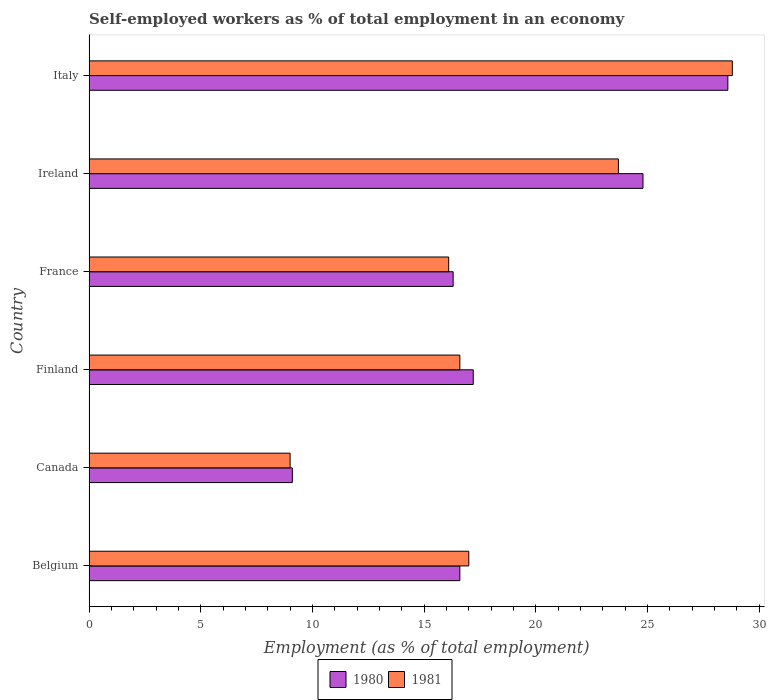How many bars are there on the 6th tick from the top?
Offer a terse response. 2. How many bars are there on the 6th tick from the bottom?
Provide a short and direct response. 2. What is the label of the 2nd group of bars from the top?
Offer a very short reply. Ireland. What is the percentage of self-employed workers in 1980 in Belgium?
Keep it short and to the point. 16.6. Across all countries, what is the maximum percentage of self-employed workers in 1981?
Provide a short and direct response. 28.8. Across all countries, what is the minimum percentage of self-employed workers in 1981?
Offer a very short reply. 9. In which country was the percentage of self-employed workers in 1981 minimum?
Offer a terse response. Canada. What is the total percentage of self-employed workers in 1981 in the graph?
Make the answer very short. 111.2. What is the difference between the percentage of self-employed workers in 1981 in Belgium and that in Italy?
Give a very brief answer. -11.8. What is the average percentage of self-employed workers in 1981 per country?
Your answer should be compact. 18.53. What is the difference between the percentage of self-employed workers in 1981 and percentage of self-employed workers in 1980 in Canada?
Your answer should be very brief. -0.1. In how many countries, is the percentage of self-employed workers in 1981 greater than 11 %?
Your answer should be compact. 5. What is the ratio of the percentage of self-employed workers in 1981 in Finland to that in France?
Offer a terse response. 1.03. Is the difference between the percentage of self-employed workers in 1981 in Belgium and Ireland greater than the difference between the percentage of self-employed workers in 1980 in Belgium and Ireland?
Your response must be concise. Yes. What is the difference between the highest and the second highest percentage of self-employed workers in 1980?
Keep it short and to the point. 3.8. What is the difference between the highest and the lowest percentage of self-employed workers in 1980?
Provide a succinct answer. 19.5. Is the sum of the percentage of self-employed workers in 1981 in Belgium and Finland greater than the maximum percentage of self-employed workers in 1980 across all countries?
Provide a short and direct response. Yes. What does the 2nd bar from the top in Italy represents?
Give a very brief answer. 1980. How many countries are there in the graph?
Provide a succinct answer. 6. What is the difference between two consecutive major ticks on the X-axis?
Offer a terse response. 5. Does the graph contain grids?
Provide a short and direct response. No. Where does the legend appear in the graph?
Ensure brevity in your answer.  Bottom center. How many legend labels are there?
Give a very brief answer. 2. What is the title of the graph?
Give a very brief answer. Self-employed workers as % of total employment in an economy. What is the label or title of the X-axis?
Make the answer very short. Employment (as % of total employment). What is the label or title of the Y-axis?
Provide a short and direct response. Country. What is the Employment (as % of total employment) of 1980 in Belgium?
Give a very brief answer. 16.6. What is the Employment (as % of total employment) in 1981 in Belgium?
Make the answer very short. 17. What is the Employment (as % of total employment) of 1980 in Canada?
Provide a short and direct response. 9.1. What is the Employment (as % of total employment) of 1981 in Canada?
Make the answer very short. 9. What is the Employment (as % of total employment) in 1980 in Finland?
Offer a very short reply. 17.2. What is the Employment (as % of total employment) of 1981 in Finland?
Your answer should be compact. 16.6. What is the Employment (as % of total employment) in 1980 in France?
Ensure brevity in your answer.  16.3. What is the Employment (as % of total employment) in 1981 in France?
Give a very brief answer. 16.1. What is the Employment (as % of total employment) of 1980 in Ireland?
Provide a short and direct response. 24.8. What is the Employment (as % of total employment) in 1981 in Ireland?
Your response must be concise. 23.7. What is the Employment (as % of total employment) in 1980 in Italy?
Make the answer very short. 28.6. What is the Employment (as % of total employment) in 1981 in Italy?
Your response must be concise. 28.8. Across all countries, what is the maximum Employment (as % of total employment) in 1980?
Provide a succinct answer. 28.6. Across all countries, what is the maximum Employment (as % of total employment) of 1981?
Provide a succinct answer. 28.8. Across all countries, what is the minimum Employment (as % of total employment) of 1980?
Keep it short and to the point. 9.1. Across all countries, what is the minimum Employment (as % of total employment) of 1981?
Offer a very short reply. 9. What is the total Employment (as % of total employment) in 1980 in the graph?
Provide a succinct answer. 112.6. What is the total Employment (as % of total employment) in 1981 in the graph?
Provide a short and direct response. 111.2. What is the difference between the Employment (as % of total employment) in 1980 in Belgium and that in Canada?
Your answer should be very brief. 7.5. What is the difference between the Employment (as % of total employment) of 1981 in Belgium and that in Canada?
Your response must be concise. 8. What is the difference between the Employment (as % of total employment) of 1980 in Belgium and that in Finland?
Your answer should be very brief. -0.6. What is the difference between the Employment (as % of total employment) of 1981 in Belgium and that in Finland?
Offer a very short reply. 0.4. What is the difference between the Employment (as % of total employment) of 1980 in Belgium and that in France?
Ensure brevity in your answer.  0.3. What is the difference between the Employment (as % of total employment) of 1981 in Belgium and that in Ireland?
Keep it short and to the point. -6.7. What is the difference between the Employment (as % of total employment) in 1981 in Belgium and that in Italy?
Offer a very short reply. -11.8. What is the difference between the Employment (as % of total employment) of 1980 in Canada and that in Finland?
Your response must be concise. -8.1. What is the difference between the Employment (as % of total employment) in 1981 in Canada and that in Finland?
Offer a very short reply. -7.6. What is the difference between the Employment (as % of total employment) of 1981 in Canada and that in France?
Offer a terse response. -7.1. What is the difference between the Employment (as % of total employment) in 1980 in Canada and that in Ireland?
Give a very brief answer. -15.7. What is the difference between the Employment (as % of total employment) in 1981 in Canada and that in Ireland?
Your answer should be compact. -14.7. What is the difference between the Employment (as % of total employment) in 1980 in Canada and that in Italy?
Offer a very short reply. -19.5. What is the difference between the Employment (as % of total employment) in 1981 in Canada and that in Italy?
Offer a very short reply. -19.8. What is the difference between the Employment (as % of total employment) in 1981 in Finland and that in France?
Your answer should be very brief. 0.5. What is the difference between the Employment (as % of total employment) of 1980 in Finland and that in Ireland?
Your response must be concise. -7.6. What is the difference between the Employment (as % of total employment) of 1981 in Finland and that in Italy?
Keep it short and to the point. -12.2. What is the difference between the Employment (as % of total employment) of 1981 in France and that in Italy?
Ensure brevity in your answer.  -12.7. What is the difference between the Employment (as % of total employment) of 1981 in Ireland and that in Italy?
Provide a succinct answer. -5.1. What is the difference between the Employment (as % of total employment) of 1980 in Belgium and the Employment (as % of total employment) of 1981 in Finland?
Provide a short and direct response. 0. What is the difference between the Employment (as % of total employment) of 1980 in Belgium and the Employment (as % of total employment) of 1981 in Italy?
Give a very brief answer. -12.2. What is the difference between the Employment (as % of total employment) of 1980 in Canada and the Employment (as % of total employment) of 1981 in France?
Your answer should be very brief. -7. What is the difference between the Employment (as % of total employment) of 1980 in Canada and the Employment (as % of total employment) of 1981 in Ireland?
Ensure brevity in your answer.  -14.6. What is the difference between the Employment (as % of total employment) of 1980 in Canada and the Employment (as % of total employment) of 1981 in Italy?
Your response must be concise. -19.7. What is the difference between the Employment (as % of total employment) of 1980 in Finland and the Employment (as % of total employment) of 1981 in France?
Keep it short and to the point. 1.1. What is the difference between the Employment (as % of total employment) in 1980 in Finland and the Employment (as % of total employment) in 1981 in Italy?
Provide a succinct answer. -11.6. What is the difference between the Employment (as % of total employment) in 1980 in France and the Employment (as % of total employment) in 1981 in Ireland?
Keep it short and to the point. -7.4. What is the difference between the Employment (as % of total employment) of 1980 in France and the Employment (as % of total employment) of 1981 in Italy?
Your response must be concise. -12.5. What is the difference between the Employment (as % of total employment) of 1980 in Ireland and the Employment (as % of total employment) of 1981 in Italy?
Provide a succinct answer. -4. What is the average Employment (as % of total employment) in 1980 per country?
Your response must be concise. 18.77. What is the average Employment (as % of total employment) in 1981 per country?
Provide a succinct answer. 18.53. What is the difference between the Employment (as % of total employment) in 1980 and Employment (as % of total employment) in 1981 in Belgium?
Keep it short and to the point. -0.4. What is the difference between the Employment (as % of total employment) in 1980 and Employment (as % of total employment) in 1981 in France?
Give a very brief answer. 0.2. What is the ratio of the Employment (as % of total employment) of 1980 in Belgium to that in Canada?
Offer a terse response. 1.82. What is the ratio of the Employment (as % of total employment) in 1981 in Belgium to that in Canada?
Offer a very short reply. 1.89. What is the ratio of the Employment (as % of total employment) in 1980 in Belgium to that in Finland?
Keep it short and to the point. 0.97. What is the ratio of the Employment (as % of total employment) of 1981 in Belgium to that in Finland?
Offer a very short reply. 1.02. What is the ratio of the Employment (as % of total employment) in 1980 in Belgium to that in France?
Make the answer very short. 1.02. What is the ratio of the Employment (as % of total employment) of 1981 in Belgium to that in France?
Provide a succinct answer. 1.06. What is the ratio of the Employment (as % of total employment) of 1980 in Belgium to that in Ireland?
Make the answer very short. 0.67. What is the ratio of the Employment (as % of total employment) in 1981 in Belgium to that in Ireland?
Offer a very short reply. 0.72. What is the ratio of the Employment (as % of total employment) in 1980 in Belgium to that in Italy?
Provide a short and direct response. 0.58. What is the ratio of the Employment (as % of total employment) in 1981 in Belgium to that in Italy?
Give a very brief answer. 0.59. What is the ratio of the Employment (as % of total employment) of 1980 in Canada to that in Finland?
Provide a short and direct response. 0.53. What is the ratio of the Employment (as % of total employment) of 1981 in Canada to that in Finland?
Your answer should be very brief. 0.54. What is the ratio of the Employment (as % of total employment) in 1980 in Canada to that in France?
Give a very brief answer. 0.56. What is the ratio of the Employment (as % of total employment) of 1981 in Canada to that in France?
Your answer should be very brief. 0.56. What is the ratio of the Employment (as % of total employment) in 1980 in Canada to that in Ireland?
Provide a succinct answer. 0.37. What is the ratio of the Employment (as % of total employment) of 1981 in Canada to that in Ireland?
Make the answer very short. 0.38. What is the ratio of the Employment (as % of total employment) of 1980 in Canada to that in Italy?
Provide a succinct answer. 0.32. What is the ratio of the Employment (as % of total employment) in 1981 in Canada to that in Italy?
Give a very brief answer. 0.31. What is the ratio of the Employment (as % of total employment) in 1980 in Finland to that in France?
Offer a very short reply. 1.06. What is the ratio of the Employment (as % of total employment) in 1981 in Finland to that in France?
Your answer should be compact. 1.03. What is the ratio of the Employment (as % of total employment) of 1980 in Finland to that in Ireland?
Make the answer very short. 0.69. What is the ratio of the Employment (as % of total employment) in 1981 in Finland to that in Ireland?
Offer a very short reply. 0.7. What is the ratio of the Employment (as % of total employment) of 1980 in Finland to that in Italy?
Give a very brief answer. 0.6. What is the ratio of the Employment (as % of total employment) of 1981 in Finland to that in Italy?
Make the answer very short. 0.58. What is the ratio of the Employment (as % of total employment) of 1980 in France to that in Ireland?
Provide a short and direct response. 0.66. What is the ratio of the Employment (as % of total employment) of 1981 in France to that in Ireland?
Provide a succinct answer. 0.68. What is the ratio of the Employment (as % of total employment) in 1980 in France to that in Italy?
Ensure brevity in your answer.  0.57. What is the ratio of the Employment (as % of total employment) in 1981 in France to that in Italy?
Ensure brevity in your answer.  0.56. What is the ratio of the Employment (as % of total employment) in 1980 in Ireland to that in Italy?
Your response must be concise. 0.87. What is the ratio of the Employment (as % of total employment) in 1981 in Ireland to that in Italy?
Your answer should be compact. 0.82. What is the difference between the highest and the second highest Employment (as % of total employment) of 1980?
Ensure brevity in your answer.  3.8. What is the difference between the highest and the second highest Employment (as % of total employment) of 1981?
Offer a terse response. 5.1. What is the difference between the highest and the lowest Employment (as % of total employment) in 1980?
Your answer should be very brief. 19.5. What is the difference between the highest and the lowest Employment (as % of total employment) in 1981?
Your response must be concise. 19.8. 